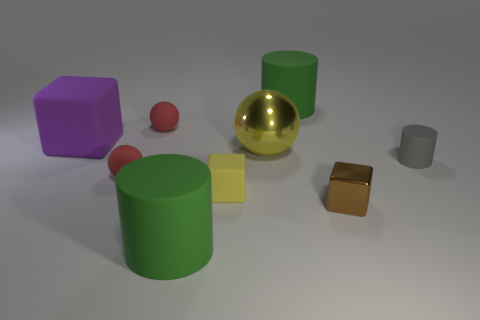The other rubber object that is the same shape as the big purple object is what color?
Your response must be concise. Yellow. What color is the rubber block that is the same size as the metallic block?
Provide a short and direct response. Yellow. Is the material of the brown cube the same as the gray thing?
Ensure brevity in your answer.  No. How many small cubes are the same color as the large block?
Your answer should be very brief. 0. Is the large metallic thing the same color as the tiny metallic cube?
Ensure brevity in your answer.  No. There is a big green cylinder behind the brown block; what is its material?
Make the answer very short. Rubber. What number of small things are either brown cubes or brown rubber cubes?
Give a very brief answer. 1. There is a tiny cube that is the same color as the metallic ball; what material is it?
Make the answer very short. Rubber. Is there a small cylinder that has the same material as the large purple thing?
Ensure brevity in your answer.  Yes. Does the green cylinder that is behind the purple thing have the same size as the tiny brown metal cube?
Your answer should be very brief. No. 